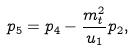Convert formula to latex. <formula><loc_0><loc_0><loc_500><loc_500>p _ { 5 } = p _ { 4 } - \frac { m _ { t } ^ { 2 } } { u _ { 1 } } p _ { 2 } ,</formula> 